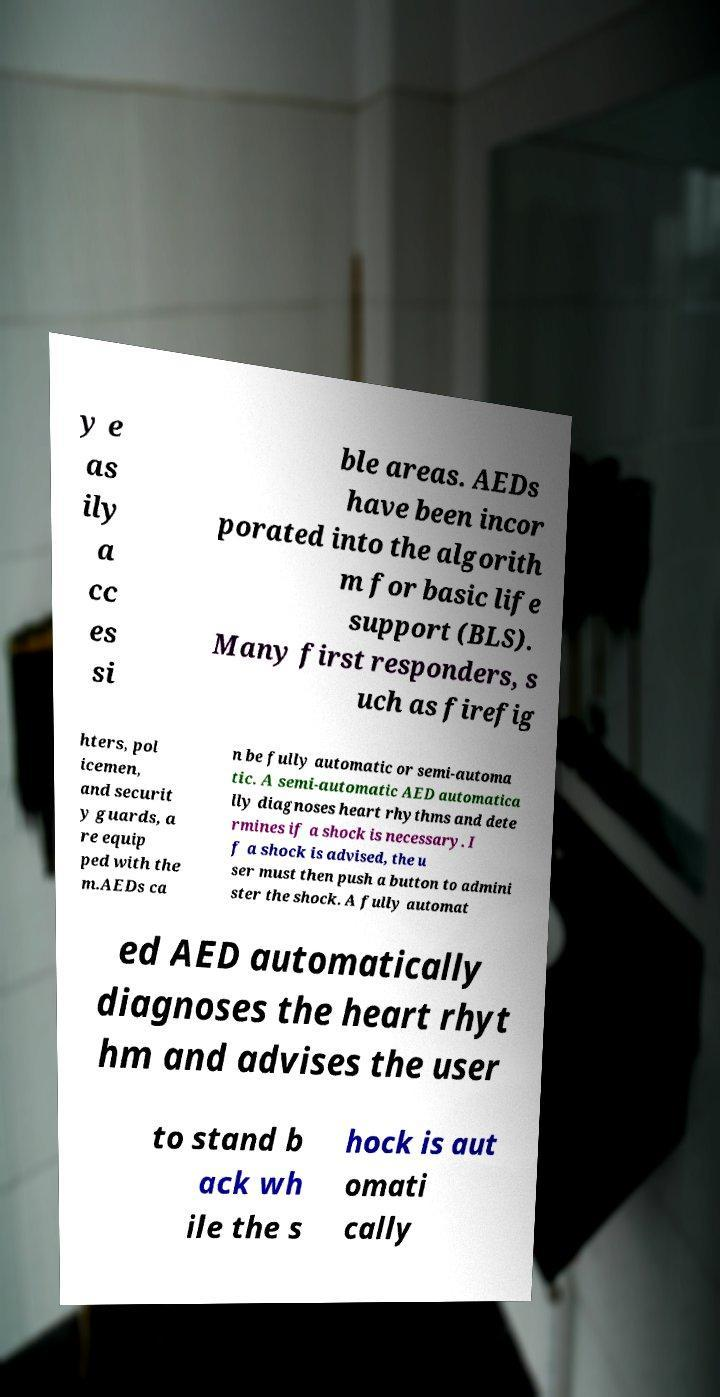For documentation purposes, I need the text within this image transcribed. Could you provide that? y e as ily a cc es si ble areas. AEDs have been incor porated into the algorith m for basic life support (BLS). Many first responders, s uch as firefig hters, pol icemen, and securit y guards, a re equip ped with the m.AEDs ca n be fully automatic or semi-automa tic. A semi-automatic AED automatica lly diagnoses heart rhythms and dete rmines if a shock is necessary. I f a shock is advised, the u ser must then push a button to admini ster the shock. A fully automat ed AED automatically diagnoses the heart rhyt hm and advises the user to stand b ack wh ile the s hock is aut omati cally 